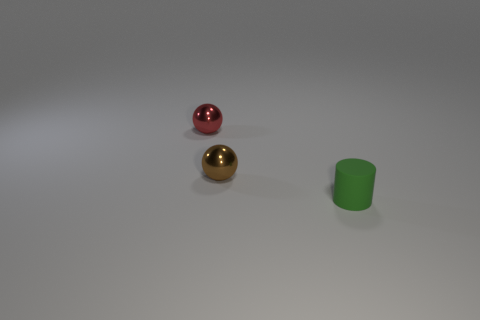Are there fewer spheres right of the small matte cylinder than small red balls right of the tiny red metal sphere?
Make the answer very short. No. Are there any other things that are the same shape as the tiny brown object?
Ensure brevity in your answer.  Yes. Do the tiny red object and the small brown metal thing have the same shape?
Your answer should be very brief. Yes. Are there any other things that are the same material as the cylinder?
Your answer should be compact. No. What is the size of the brown thing?
Give a very brief answer. Small. What is the color of the small object that is both behind the small green matte object and on the right side of the small red metal thing?
Your answer should be compact. Brown. Are there more red metallic objects than blue metal cylinders?
Give a very brief answer. Yes. How many things are either large brown cylinders or small metallic balls behind the small brown metallic sphere?
Offer a very short reply. 1. Is the red object the same size as the rubber object?
Your answer should be very brief. Yes. Are there any metallic things in front of the small brown ball?
Make the answer very short. No. 